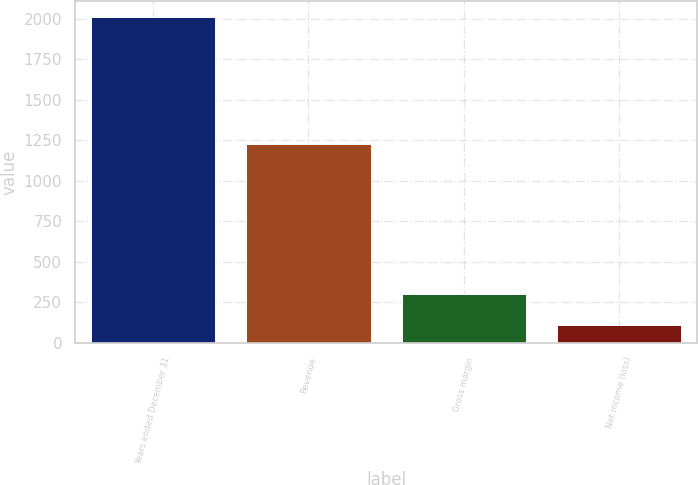<chart> <loc_0><loc_0><loc_500><loc_500><bar_chart><fcel>Years ended December 31<fcel>Revenue<fcel>Gross margin<fcel>Net income (loss)<nl><fcel>2009<fcel>1229<fcel>299.9<fcel>110<nl></chart> 